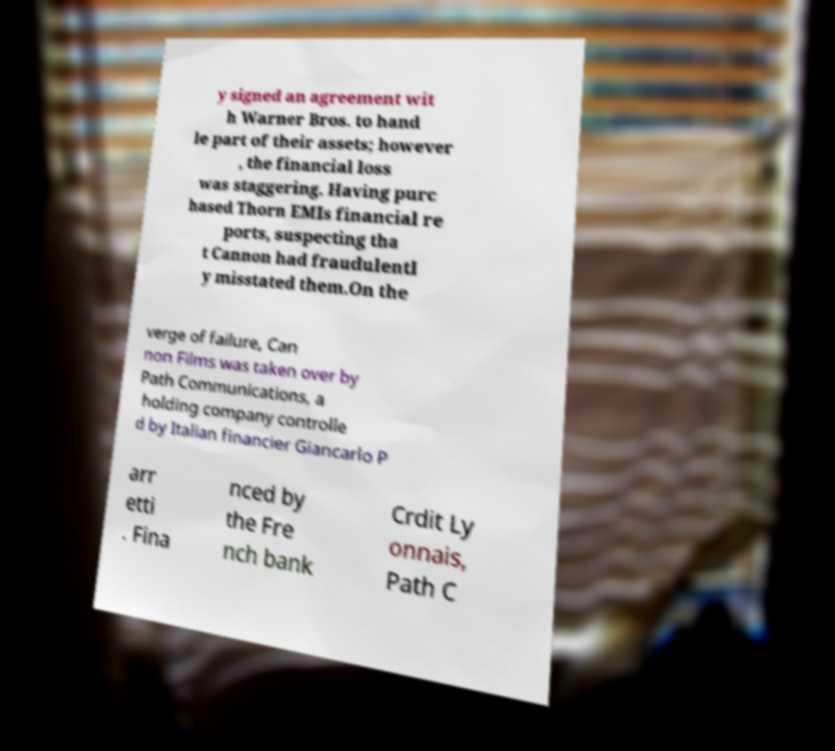Please identify and transcribe the text found in this image. y signed an agreement wit h Warner Bros. to hand le part of their assets; however , the financial loss was staggering. Having purc hased Thorn EMIs financial re ports, suspecting tha t Cannon had fraudulentl y misstated them.On the verge of failure, Can non Films was taken over by Path Communications, a holding company controlle d by Italian financier Giancarlo P arr etti . Fina nced by the Fre nch bank Crdit Ly onnais, Path C 